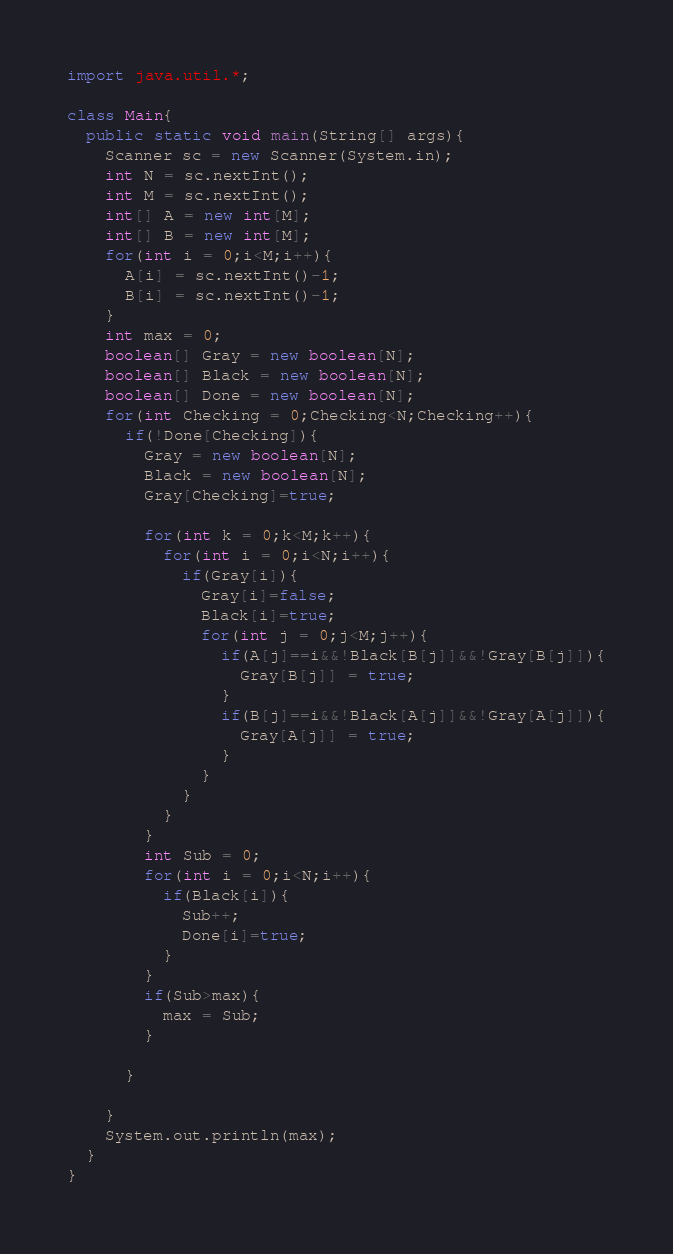<code> <loc_0><loc_0><loc_500><loc_500><_Java_>import java.util.*;

class Main{
  public static void main(String[] args){
    Scanner sc = new Scanner(System.in);
    int N = sc.nextInt();
    int M = sc.nextInt();
    int[] A = new int[M];
    int[] B = new int[M];
    for(int i = 0;i<M;i++){
      A[i] = sc.nextInt()-1;
      B[i] = sc.nextInt()-1;
    }
    int max = 0;
    boolean[] Gray = new boolean[N];
    boolean[] Black = new boolean[N];
    boolean[] Done = new boolean[N];
    for(int Checking = 0;Checking<N;Checking++){
      if(!Done[Checking]){
        Gray = new boolean[N];
        Black = new boolean[N];
        Gray[Checking]=true;
        
        for(int k = 0;k<M;k++){
          for(int i = 0;i<N;i++){
        	if(Gray[i]){
         	  Gray[i]=false;
          	  Black[i]=true;
           	  for(int j = 0;j<M;j++){
           	    if(A[j]==i&&!Black[B[j]]&&!Gray[B[j]]){
           	      Gray[B[j]] = true;
           	    }
                if(B[j]==i&&!Black[A[j]]&&!Gray[A[j]]){
           	      Gray[A[j]] = true;
           	    }
          	  }
            }
       	  }
        }
        int Sub = 0;
        for(int i = 0;i<N;i++){
          if(Black[i]){
            Sub++;
            Done[i]=true;
          }
        }
        if(Sub>max){
          max = Sub;
        }
        
      }
      
    }
    System.out.println(max);
  }
}</code> 